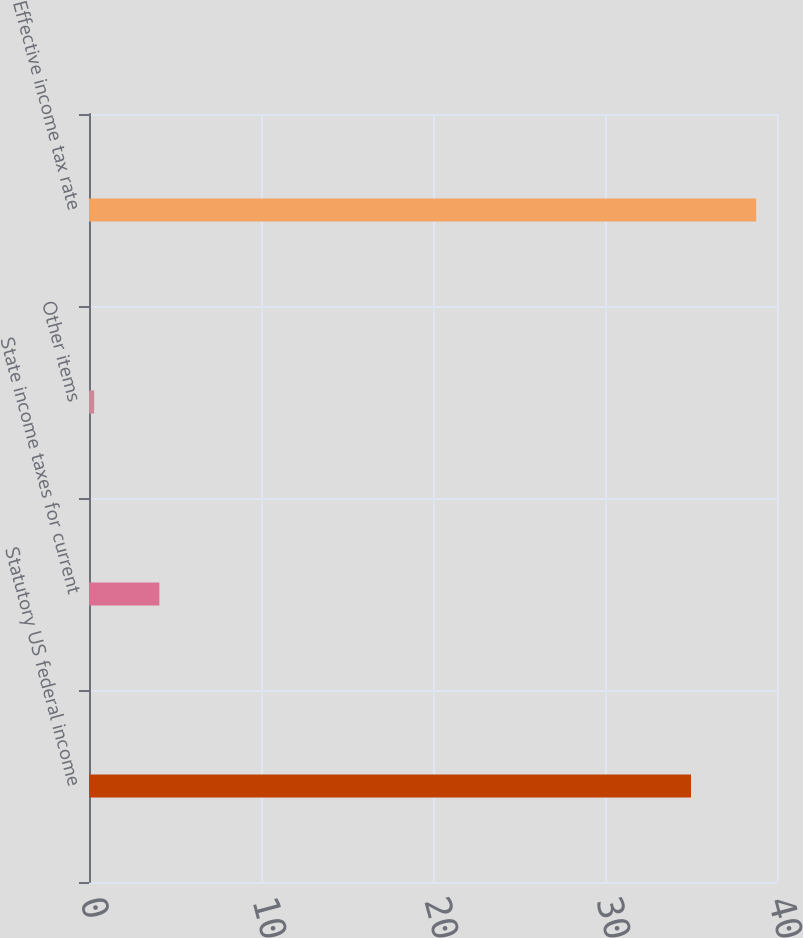Convert chart. <chart><loc_0><loc_0><loc_500><loc_500><bar_chart><fcel>Statutory US federal income<fcel>State income taxes for current<fcel>Other items<fcel>Effective income tax rate<nl><fcel>35<fcel>4.09<fcel>0.3<fcel>38.79<nl></chart> 